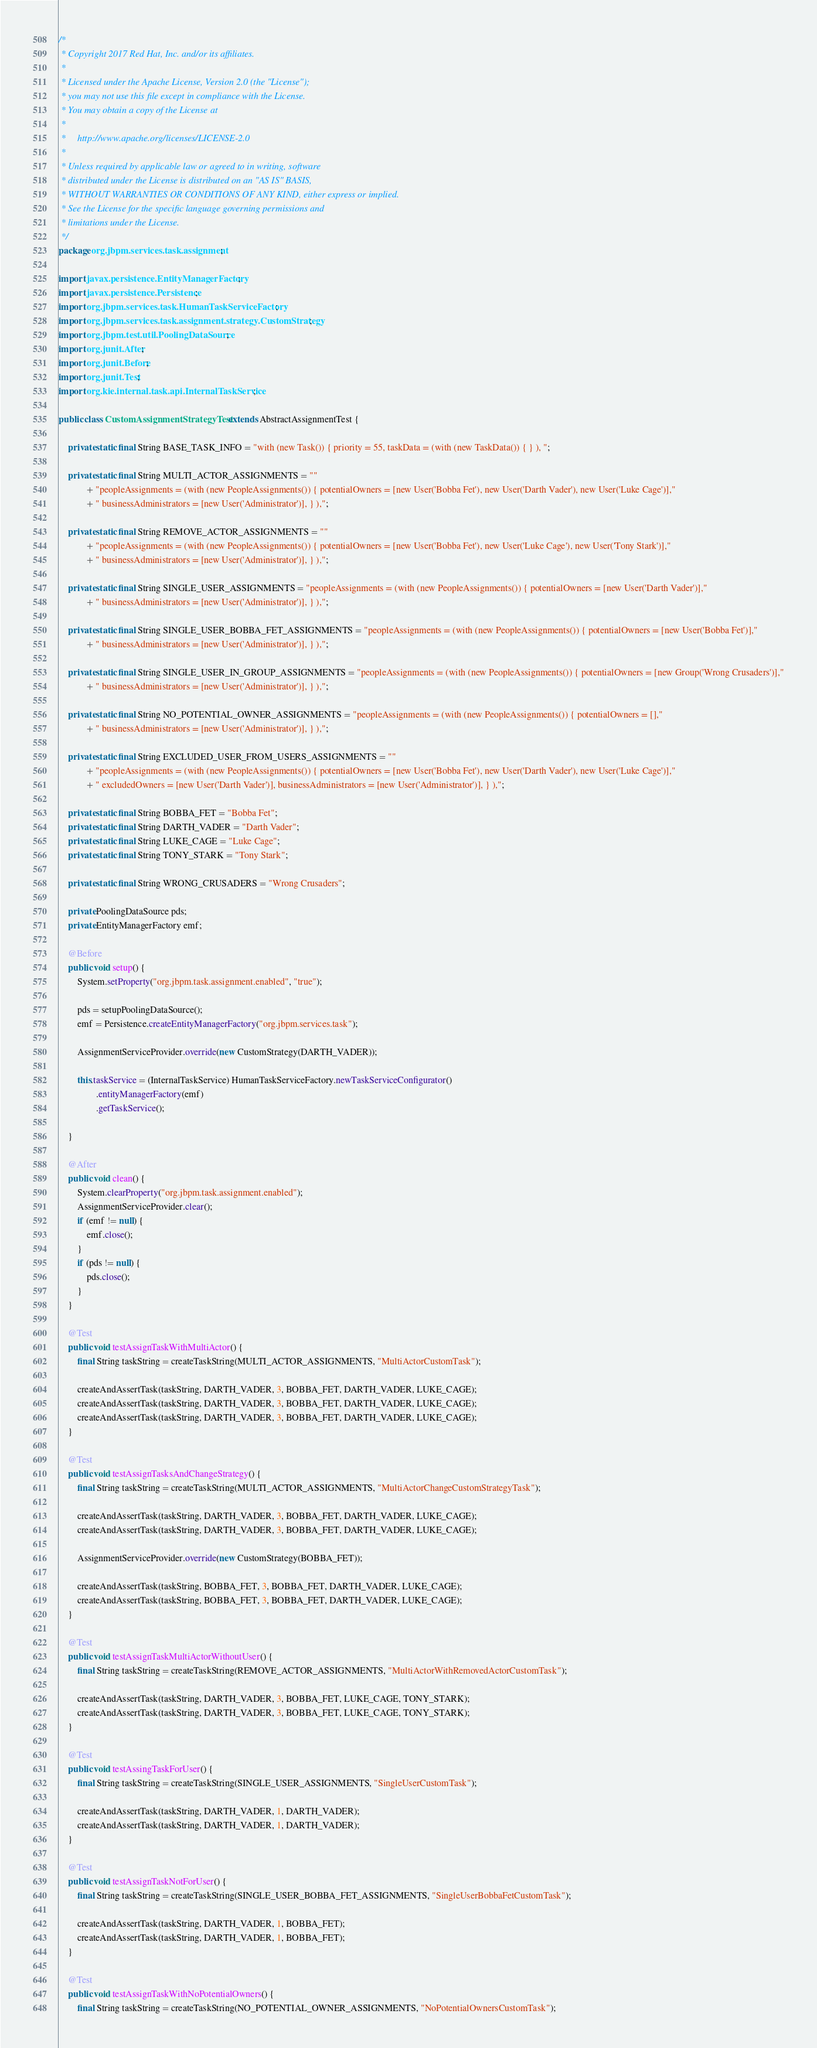Convert code to text. <code><loc_0><loc_0><loc_500><loc_500><_Java_>/*
 * Copyright 2017 Red Hat, Inc. and/or its affiliates.
 *
 * Licensed under the Apache License, Version 2.0 (the "License");
 * you may not use this file except in compliance with the License.
 * You may obtain a copy of the License at
 *
 *     http://www.apache.org/licenses/LICENSE-2.0
 *
 * Unless required by applicable law or agreed to in writing, software
 * distributed under the License is distributed on an "AS IS" BASIS,
 * WITHOUT WARRANTIES OR CONDITIONS OF ANY KIND, either express or implied.
 * See the License for the specific language governing permissions and
 * limitations under the License.
 */
package org.jbpm.services.task.assignment;

import javax.persistence.EntityManagerFactory;
import javax.persistence.Persistence;
import org.jbpm.services.task.HumanTaskServiceFactory;
import org.jbpm.services.task.assignment.strategy.CustomStrategy;
import org.jbpm.test.util.PoolingDataSource;
import org.junit.After;
import org.junit.Before;
import org.junit.Test;
import org.kie.internal.task.api.InternalTaskService;

public class CustomAssignmentStrategyTest extends AbstractAssignmentTest {

    private static final String BASE_TASK_INFO = "with (new Task()) { priority = 55, taskData = (with (new TaskData()) { } ), ";

    private static final String MULTI_ACTOR_ASSIGNMENTS = ""
            + "peopleAssignments = (with (new PeopleAssignments()) { potentialOwners = [new User('Bobba Fet'), new User('Darth Vader'), new User('Luke Cage')],"
            + " businessAdministrators = [new User('Administrator')], } ),";

    private static final String REMOVE_ACTOR_ASSIGNMENTS = ""
            + "peopleAssignments = (with (new PeopleAssignments()) { potentialOwners = [new User('Bobba Fet'), new User('Luke Cage'), new User('Tony Stark')],"
            + " businessAdministrators = [new User('Administrator')], } ),";

    private static final String SINGLE_USER_ASSIGNMENTS = "peopleAssignments = (with (new PeopleAssignments()) { potentialOwners = [new User('Darth Vader')],"
            + " businessAdministrators = [new User('Administrator')], } ),";

    private static final String SINGLE_USER_BOBBA_FET_ASSIGNMENTS = "peopleAssignments = (with (new PeopleAssignments()) { potentialOwners = [new User('Bobba Fet')],"
            + " businessAdministrators = [new User('Administrator')], } ),";

    private static final String SINGLE_USER_IN_GROUP_ASSIGNMENTS = "peopleAssignments = (with (new PeopleAssignments()) { potentialOwners = [new Group('Wrong Crusaders')],"
            + " businessAdministrators = [new User('Administrator')], } ),";

    private static final String NO_POTENTIAL_OWNER_ASSIGNMENTS = "peopleAssignments = (with (new PeopleAssignments()) { potentialOwners = [],"
            + " businessAdministrators = [new User('Administrator')], } ),";

    private static final String EXCLUDED_USER_FROM_USERS_ASSIGNMENTS = ""
            + "peopleAssignments = (with (new PeopleAssignments()) { potentialOwners = [new User('Bobba Fet'), new User('Darth Vader'), new User('Luke Cage')],"
            + " excludedOwners = [new User('Darth Vader')], businessAdministrators = [new User('Administrator')], } ),";

    private static final String BOBBA_FET = "Bobba Fet";
    private static final String DARTH_VADER = "Darth Vader";
    private static final String LUKE_CAGE = "Luke Cage";
    private static final String TONY_STARK = "Tony Stark";

    private static final String WRONG_CRUSADERS = "Wrong Crusaders";

    private PoolingDataSource pds;
    private EntityManagerFactory emf;

    @Before
    public void setup() {
        System.setProperty("org.jbpm.task.assignment.enabled", "true");

        pds = setupPoolingDataSource();
        emf = Persistence.createEntityManagerFactory("org.jbpm.services.task");

        AssignmentServiceProvider.override(new CustomStrategy(DARTH_VADER));

        this.taskService = (InternalTaskService) HumanTaskServiceFactory.newTaskServiceConfigurator()
                .entityManagerFactory(emf)
                .getTaskService();

    }

    @After
    public void clean() {
        System.clearProperty("org.jbpm.task.assignment.enabled");
        AssignmentServiceProvider.clear();
        if (emf != null) {
            emf.close();
        }
        if (pds != null) {
            pds.close();
        }
    }

    @Test
    public void testAssignTaskWithMultiActor() {
        final String taskString = createTaskString(MULTI_ACTOR_ASSIGNMENTS, "MultiActorCustomTask");

        createAndAssertTask(taskString, DARTH_VADER, 3, BOBBA_FET, DARTH_VADER, LUKE_CAGE);
        createAndAssertTask(taskString, DARTH_VADER, 3, BOBBA_FET, DARTH_VADER, LUKE_CAGE);
        createAndAssertTask(taskString, DARTH_VADER, 3, BOBBA_FET, DARTH_VADER, LUKE_CAGE);
    }

    @Test
    public void testAssignTasksAndChangeStrategy() {
        final String taskString = createTaskString(MULTI_ACTOR_ASSIGNMENTS, "MultiActorChangeCustomStrategyTask");

        createAndAssertTask(taskString, DARTH_VADER, 3, BOBBA_FET, DARTH_VADER, LUKE_CAGE);
        createAndAssertTask(taskString, DARTH_VADER, 3, BOBBA_FET, DARTH_VADER, LUKE_CAGE);

        AssignmentServiceProvider.override(new CustomStrategy(BOBBA_FET));

        createAndAssertTask(taskString, BOBBA_FET, 3, BOBBA_FET, DARTH_VADER, LUKE_CAGE);
        createAndAssertTask(taskString, BOBBA_FET, 3, BOBBA_FET, DARTH_VADER, LUKE_CAGE);
    }

    @Test
    public void testAssignTaskMultiActorWithoutUser() {
        final String taskString = createTaskString(REMOVE_ACTOR_ASSIGNMENTS, "MultiActorWithRemovedActorCustomTask");

        createAndAssertTask(taskString, DARTH_VADER, 3, BOBBA_FET, LUKE_CAGE, TONY_STARK);
        createAndAssertTask(taskString, DARTH_VADER, 3, BOBBA_FET, LUKE_CAGE, TONY_STARK);
    }

    @Test
    public void testAssingTaskForUser() {
        final String taskString = createTaskString(SINGLE_USER_ASSIGNMENTS, "SingleUserCustomTask");

        createAndAssertTask(taskString, DARTH_VADER, 1, DARTH_VADER);
        createAndAssertTask(taskString, DARTH_VADER, 1, DARTH_VADER);
    }

    @Test
    public void testAssignTaskNotForUser() {
        final String taskString = createTaskString(SINGLE_USER_BOBBA_FET_ASSIGNMENTS, "SingleUserBobbaFetCustomTask");

        createAndAssertTask(taskString, DARTH_VADER, 1, BOBBA_FET);
        createAndAssertTask(taskString, DARTH_VADER, 1, BOBBA_FET);
    }

    @Test
    public void testAssignTaskWithNoPotentialOwners() {
        final String taskString = createTaskString(NO_POTENTIAL_OWNER_ASSIGNMENTS, "NoPotentialOwnersCustomTask");
</code> 